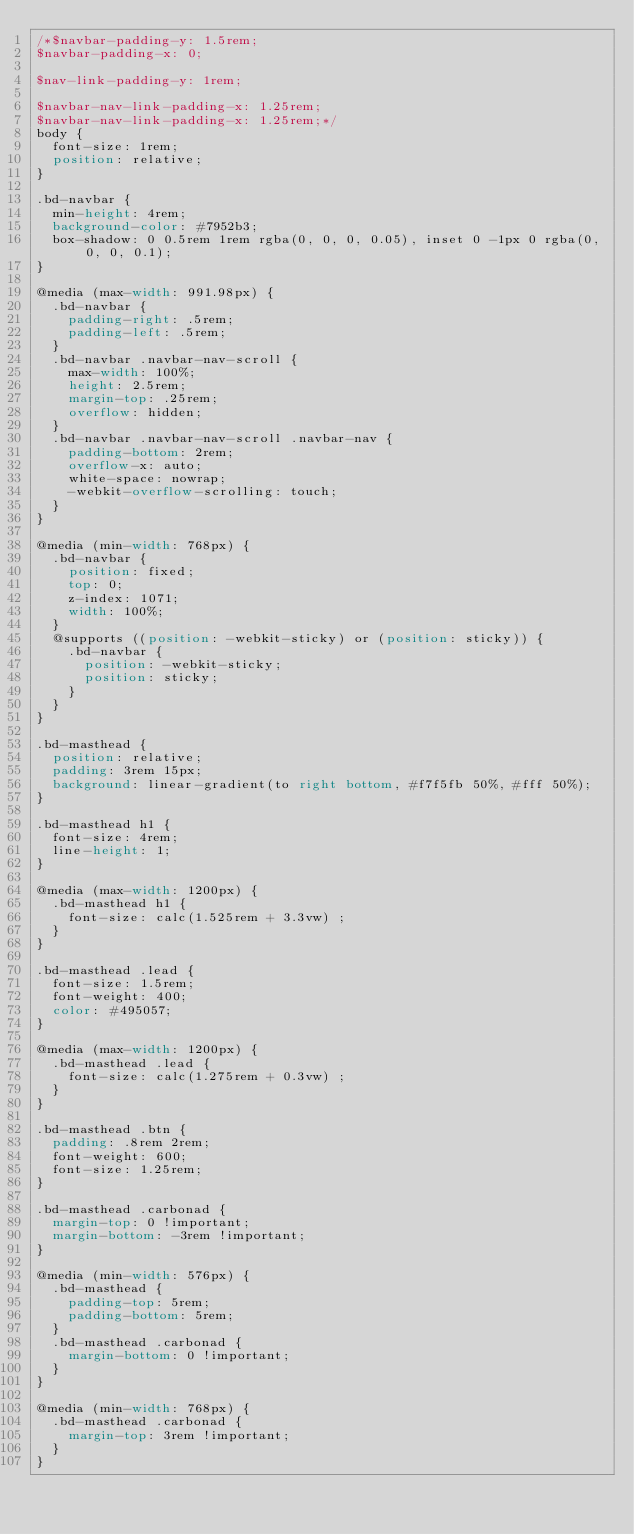<code> <loc_0><loc_0><loc_500><loc_500><_CSS_>/*$navbar-padding-y: 1.5rem;
$navbar-padding-x: 0;

$nav-link-padding-y: 1rem;

$navbar-nav-link-padding-x: 1.25rem;
$navbar-nav-link-padding-x: 1.25rem;*/
body {
  font-size: 1rem;
  position: relative;
}

.bd-navbar {
  min-height: 4rem;
  background-color: #7952b3;
  box-shadow: 0 0.5rem 1rem rgba(0, 0, 0, 0.05), inset 0 -1px 0 rgba(0, 0, 0, 0.1);
}

@media (max-width: 991.98px) {
  .bd-navbar {
    padding-right: .5rem;
    padding-left: .5rem;
  }
  .bd-navbar .navbar-nav-scroll {
    max-width: 100%;
    height: 2.5rem;
    margin-top: .25rem;
    overflow: hidden;
  }
  .bd-navbar .navbar-nav-scroll .navbar-nav {
    padding-bottom: 2rem;
    overflow-x: auto;
    white-space: nowrap;
    -webkit-overflow-scrolling: touch;
  }
}

@media (min-width: 768px) {
  .bd-navbar {
    position: fixed;
    top: 0;
    z-index: 1071;
    width: 100%;
  }
  @supports ((position: -webkit-sticky) or (position: sticky)) {
    .bd-navbar {
      position: -webkit-sticky;
      position: sticky;
    }
  }
}

.bd-masthead {
  position: relative;
  padding: 3rem 15px;
  background: linear-gradient(to right bottom, #f7f5fb 50%, #fff 50%);
}

.bd-masthead h1 {
  font-size: 4rem;
  line-height: 1;
}

@media (max-width: 1200px) {
  .bd-masthead h1 {
    font-size: calc(1.525rem + 3.3vw) ;
  }
}

.bd-masthead .lead {
  font-size: 1.5rem;
  font-weight: 400;
  color: #495057;
}

@media (max-width: 1200px) {
  .bd-masthead .lead {
    font-size: calc(1.275rem + 0.3vw) ;
  }
}

.bd-masthead .btn {
  padding: .8rem 2rem;
  font-weight: 600;
  font-size: 1.25rem;
}

.bd-masthead .carbonad {
  margin-top: 0 !important;
  margin-bottom: -3rem !important;
}

@media (min-width: 576px) {
  .bd-masthead {
    padding-top: 5rem;
    padding-bottom: 5rem;
  }
  .bd-masthead .carbonad {
    margin-bottom: 0 !important;
  }
}

@media (min-width: 768px) {
  .bd-masthead .carbonad {
    margin-top: 3rem !important;
  }
}
</code> 